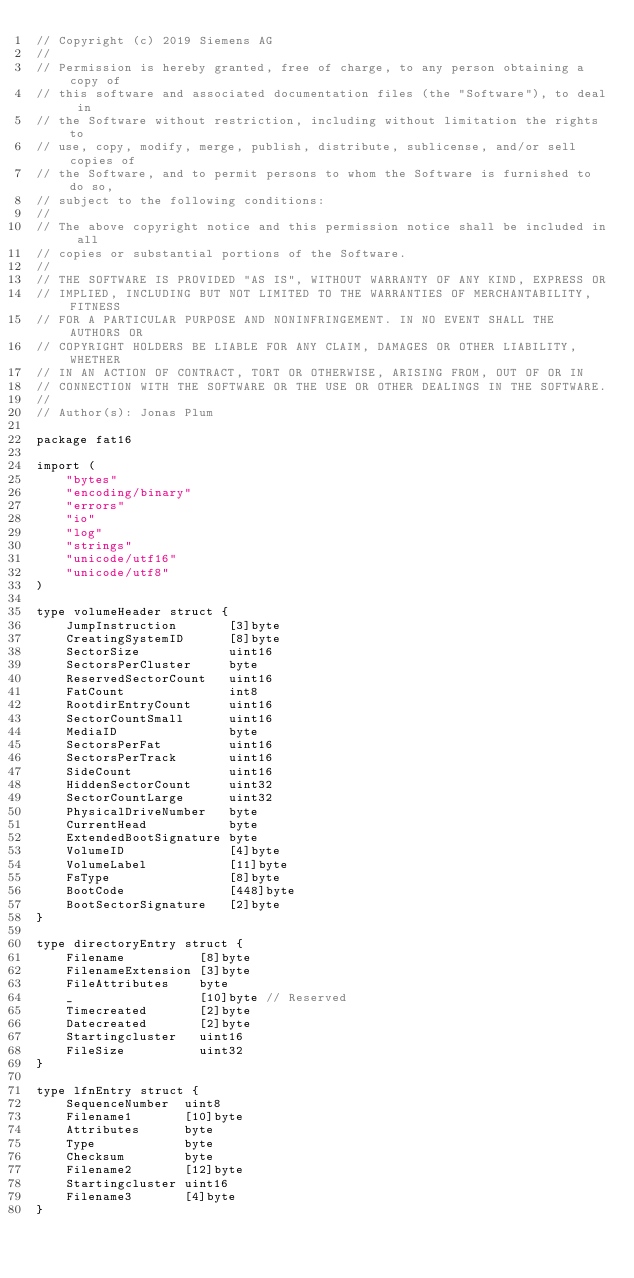<code> <loc_0><loc_0><loc_500><loc_500><_Go_>// Copyright (c) 2019 Siemens AG
//
// Permission is hereby granted, free of charge, to any person obtaining a copy of
// this software and associated documentation files (the "Software"), to deal in
// the Software without restriction, including without limitation the rights to
// use, copy, modify, merge, publish, distribute, sublicense, and/or sell copies of
// the Software, and to permit persons to whom the Software is furnished to do so,
// subject to the following conditions:
//
// The above copyright notice and this permission notice shall be included in all
// copies or substantial portions of the Software.
//
// THE SOFTWARE IS PROVIDED "AS IS", WITHOUT WARRANTY OF ANY KIND, EXPRESS OR
// IMPLIED, INCLUDING BUT NOT LIMITED TO THE WARRANTIES OF MERCHANTABILITY, FITNESS
// FOR A PARTICULAR PURPOSE AND NONINFRINGEMENT. IN NO EVENT SHALL THE AUTHORS OR
// COPYRIGHT HOLDERS BE LIABLE FOR ANY CLAIM, DAMAGES OR OTHER LIABILITY, WHETHER
// IN AN ACTION OF CONTRACT, TORT OR OTHERWISE, ARISING FROM, OUT OF OR IN
// CONNECTION WITH THE SOFTWARE OR THE USE OR OTHER DEALINGS IN THE SOFTWARE.
//
// Author(s): Jonas Plum

package fat16

import (
	"bytes"
	"encoding/binary"
	"errors"
	"io"
	"log"
	"strings"
	"unicode/utf16"
	"unicode/utf8"
)

type volumeHeader struct {
	JumpInstruction       [3]byte
	CreatingSystemID      [8]byte
	SectorSize            uint16
	SectorsPerCluster     byte
	ReservedSectorCount   uint16
	FatCount              int8
	RootdirEntryCount     uint16
	SectorCountSmall      uint16
	MediaID               byte
	SectorsPerFat         uint16
	SectorsPerTrack       uint16
	SideCount             uint16
	HiddenSectorCount     uint32
	SectorCountLarge      uint32
	PhysicalDriveNumber   byte
	CurrentHead           byte
	ExtendedBootSignature byte
	VolumeID              [4]byte
	VolumeLabel           [11]byte
	FsType                [8]byte
	BootCode              [448]byte
	BootSectorSignature   [2]byte
}

type directoryEntry struct {
	Filename          [8]byte
	FilenameExtension [3]byte
	FileAttributes    byte
	_                 [10]byte // Reserved
	Timecreated       [2]byte
	Datecreated       [2]byte
	Startingcluster   uint16
	FileSize          uint32
}

type lfnEntry struct {
	SequenceNumber  uint8
	Filename1       [10]byte
	Attributes      byte
	Type            byte
	Checksum        byte
	Filename2       [12]byte
	Startingcluster uint16
	Filename3       [4]byte
}
</code> 